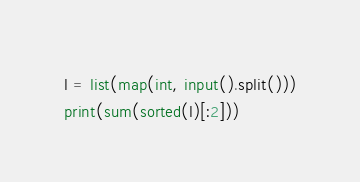Convert code to text. <code><loc_0><loc_0><loc_500><loc_500><_Python_>l = list(map(int, input().split()))
print(sum(sorted(l)[:2]))
</code> 